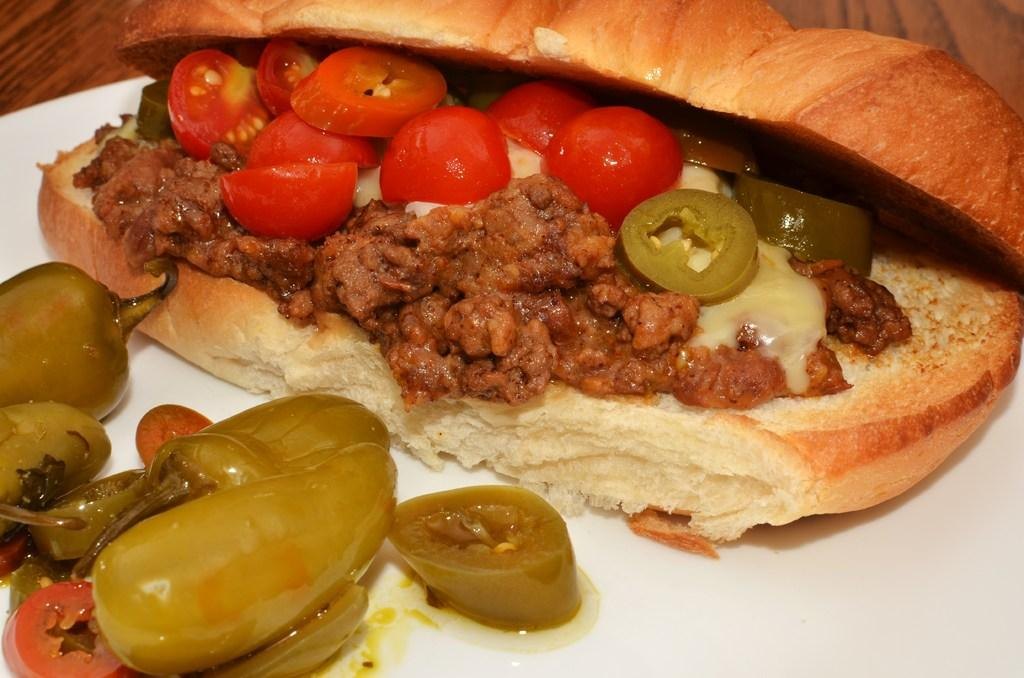What color is the plate in the image? The plate in the image is white colored. What is the plate placed on? The plate is on a brown colored table. What is on top of the plate? There is a food item on the plate. Can you describe the colors of the food item? The food item has brown, cream, red, and green colors. How many kittens are playing with the camera in the image? There are no kittens or cameras present in the image. 